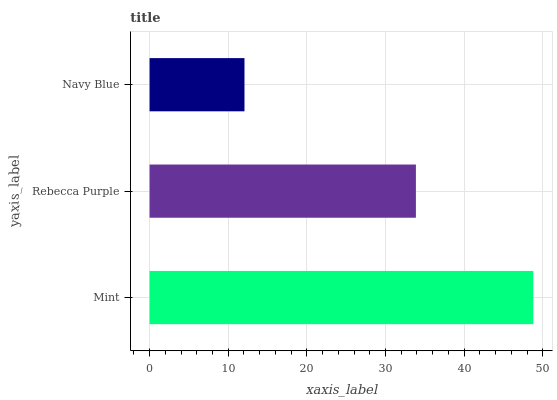Is Navy Blue the minimum?
Answer yes or no. Yes. Is Mint the maximum?
Answer yes or no. Yes. Is Rebecca Purple the minimum?
Answer yes or no. No. Is Rebecca Purple the maximum?
Answer yes or no. No. Is Mint greater than Rebecca Purple?
Answer yes or no. Yes. Is Rebecca Purple less than Mint?
Answer yes or no. Yes. Is Rebecca Purple greater than Mint?
Answer yes or no. No. Is Mint less than Rebecca Purple?
Answer yes or no. No. Is Rebecca Purple the high median?
Answer yes or no. Yes. Is Rebecca Purple the low median?
Answer yes or no. Yes. Is Mint the high median?
Answer yes or no. No. Is Navy Blue the low median?
Answer yes or no. No. 